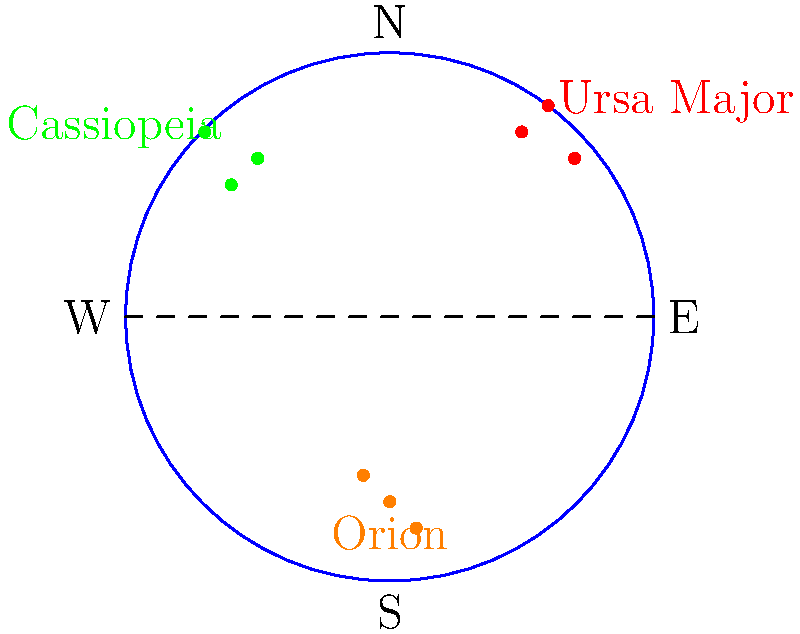As a community garden organizer planning nighttime gardening activities, which constellation among those shown in the diagram is most visible during summer evenings in the Northern Hemisphere? To answer this question, we need to consider the visibility of constellations during different seasons in the Northern Hemisphere:

1. The diagram shows three constellations: Ursa Major, Cassiopeia, and Orion.

2. Ursa Major (The Great Bear) is a circumpolar constellation for most of the Northern Hemisphere, meaning it's visible year-round. However, it's highest in the sky during spring evenings.

3. Cassiopeia is also circumpolar for most of the Northern Hemisphere and is most prominent in autumn evenings.

4. Orion is a winter constellation in the Northern Hemisphere. It becomes visible in late autumn, is prominent in winter, and disappears from view in spring.

5. During summer evenings in the Northern Hemisphere, Ursa Major is still visible high in the northwestern sky, while Cassiopeia is lower in the northeastern sky.

6. Orion is not visible during summer evenings as it's below the horizon.

Therefore, among the constellations shown, Ursa Major is the most visible and prominent during summer evenings in the Northern Hemisphere.
Answer: Ursa Major 